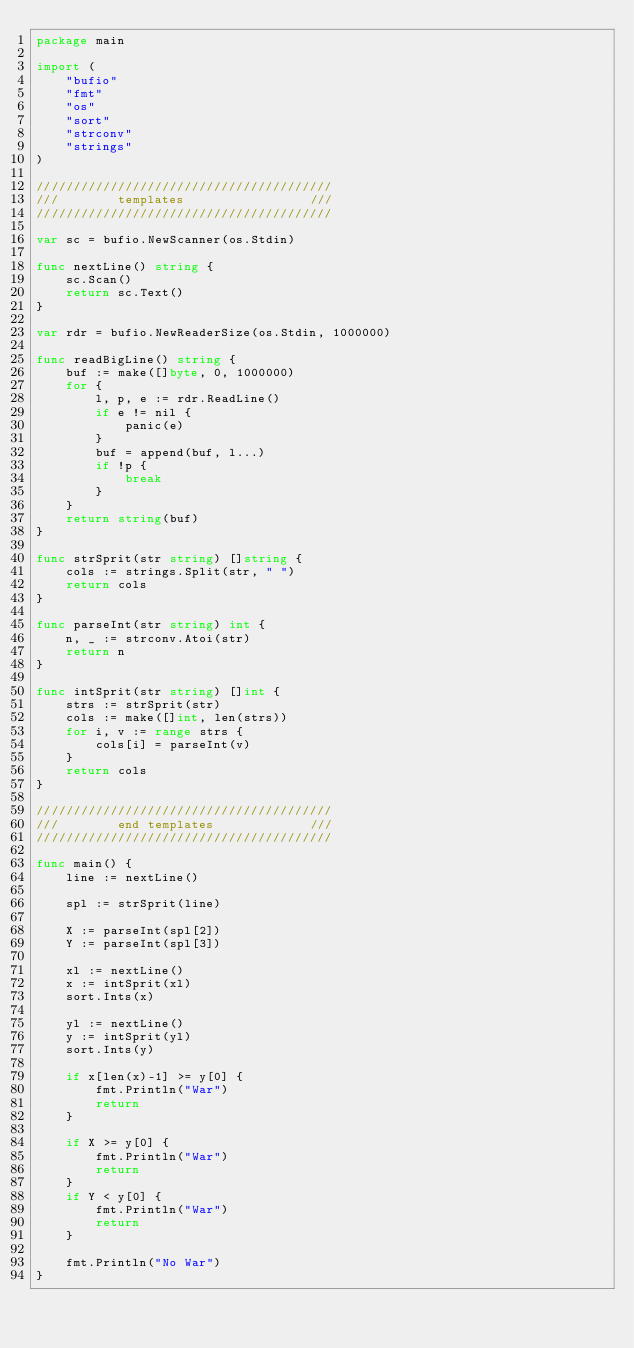<code> <loc_0><loc_0><loc_500><loc_500><_Go_>package main

import (
	"bufio"
	"fmt"
	"os"
	"sort"
	"strconv"
	"strings"
)

////////////////////////////////////////
///        templates                 ///
////////////////////////////////////////

var sc = bufio.NewScanner(os.Stdin)

func nextLine() string {
	sc.Scan()
	return sc.Text()
}

var rdr = bufio.NewReaderSize(os.Stdin, 1000000)

func readBigLine() string {
	buf := make([]byte, 0, 1000000)
	for {
		l, p, e := rdr.ReadLine()
		if e != nil {
			panic(e)
		}
		buf = append(buf, l...)
		if !p {
			break
		}
	}
	return string(buf)
}

func strSprit(str string) []string {
	cols := strings.Split(str, " ")
	return cols
}

func parseInt(str string) int {
	n, _ := strconv.Atoi(str)
	return n
}

func intSprit(str string) []int {
	strs := strSprit(str)
	cols := make([]int, len(strs))
	for i, v := range strs {
		cols[i] = parseInt(v)
	}
	return cols
}

////////////////////////////////////////
///        end templates             ///
////////////////////////////////////////

func main() {
	line := nextLine()

	spl := strSprit(line)

	X := parseInt(spl[2])
	Y := parseInt(spl[3])

	xl := nextLine()
	x := intSprit(xl)
	sort.Ints(x)

	yl := nextLine()
	y := intSprit(yl)
	sort.Ints(y)

	if x[len(x)-1] >= y[0] {
		fmt.Println("War")
		return
	}

	if X >= y[0] {
		fmt.Println("War")
		return
	}
	if Y < y[0] {
		fmt.Println("War")
		return
	}

	fmt.Println("No War")
}
</code> 